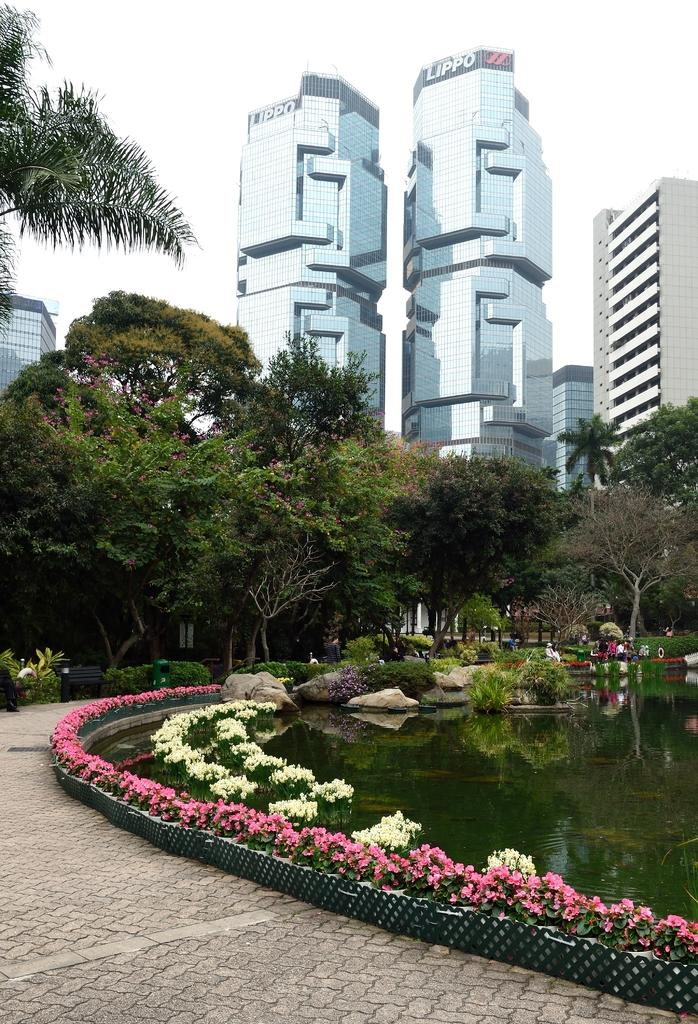What type of structures can be seen in the image? There are buildings in the image. What natural elements are present in the image? There are trees, bushes, and flowers visible in the image. What type of seating is available in the image? There are benches in the image. What can be seen at the bottom of the image? There is water visible at the bottom of the image, with stones in it. What type of pathway is present in the image? There is a road in the image. Can you tell me how many firemen are present in the image? There are no firemen present in the image. What type of selection process is being conducted in the image? There is no selection process depicted in the image. 